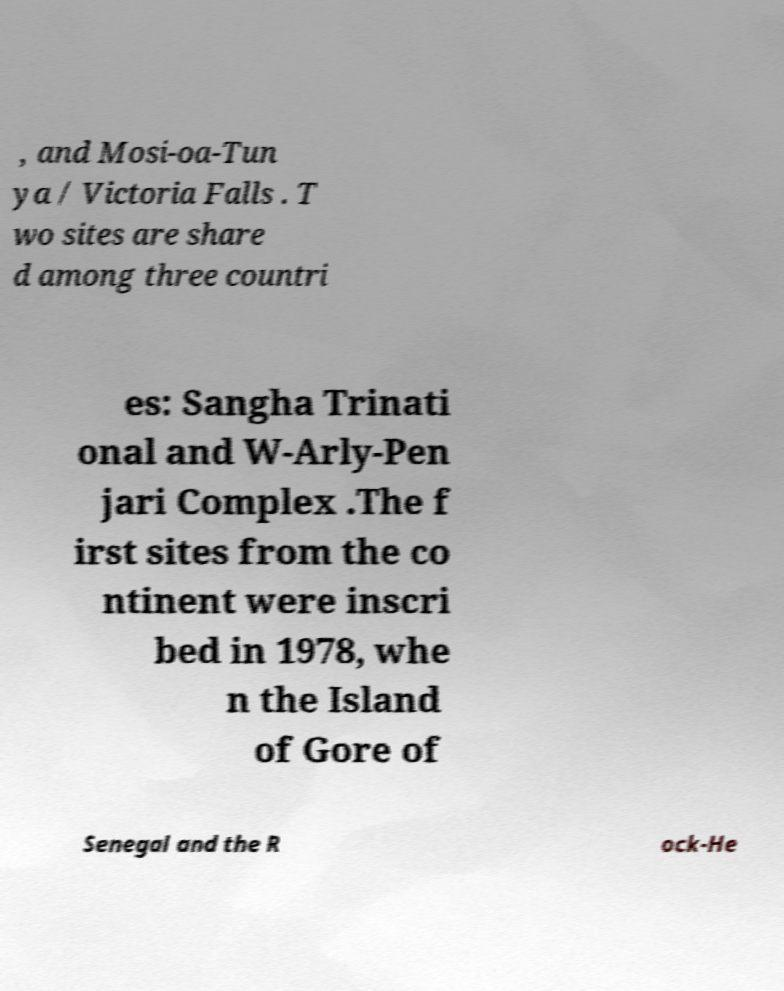What messages or text are displayed in this image? I need them in a readable, typed format. , and Mosi-oa-Tun ya / Victoria Falls . T wo sites are share d among three countri es: Sangha Trinati onal and W-Arly-Pen jari Complex .The f irst sites from the co ntinent were inscri bed in 1978, whe n the Island of Gore of Senegal and the R ock-He 